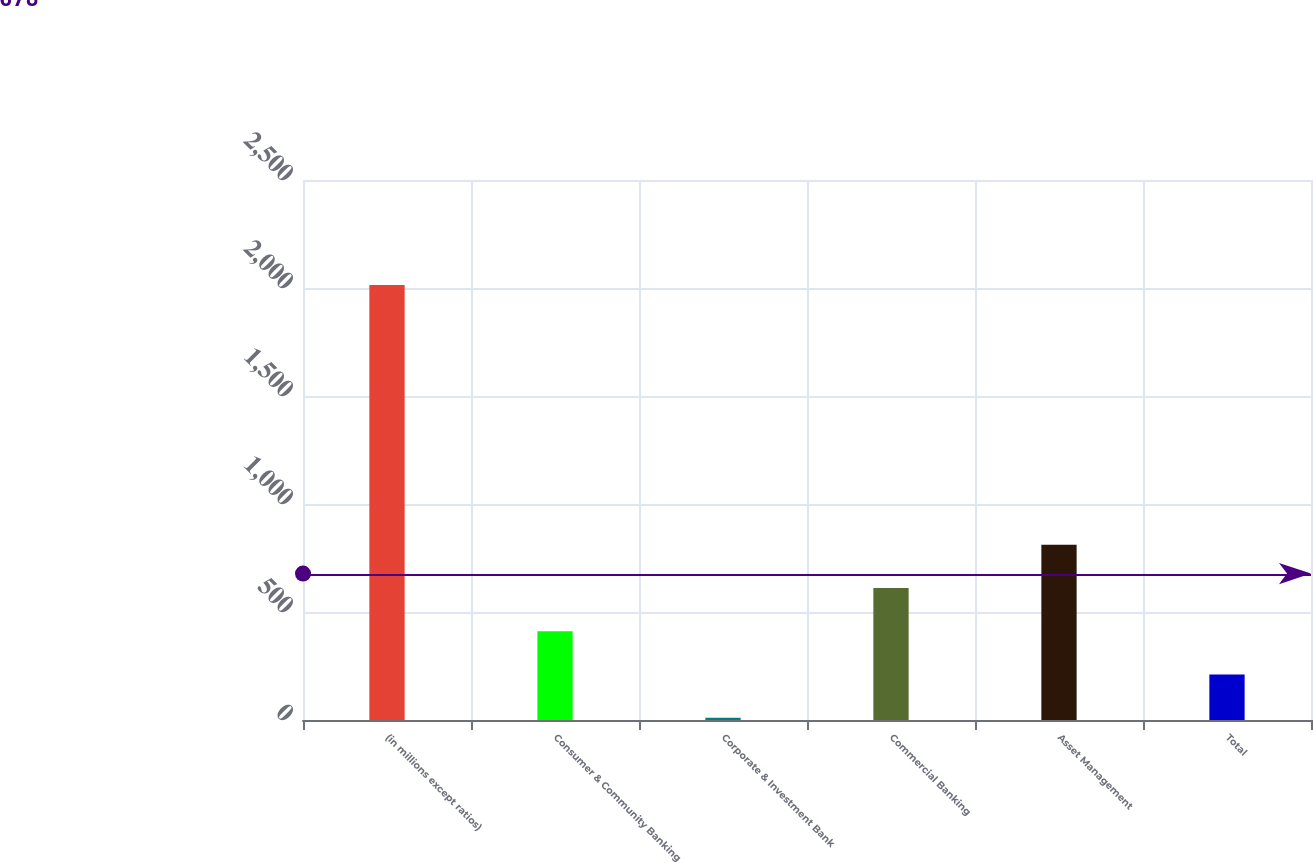<chart> <loc_0><loc_0><loc_500><loc_500><bar_chart><fcel>(in millions except ratios)<fcel>Consumer & Community Banking<fcel>Corporate & Investment Bank<fcel>Commercial Banking<fcel>Asset Management<fcel>Total<nl><fcel>2014<fcel>410.8<fcel>10<fcel>611.2<fcel>811.6<fcel>210.4<nl></chart> 